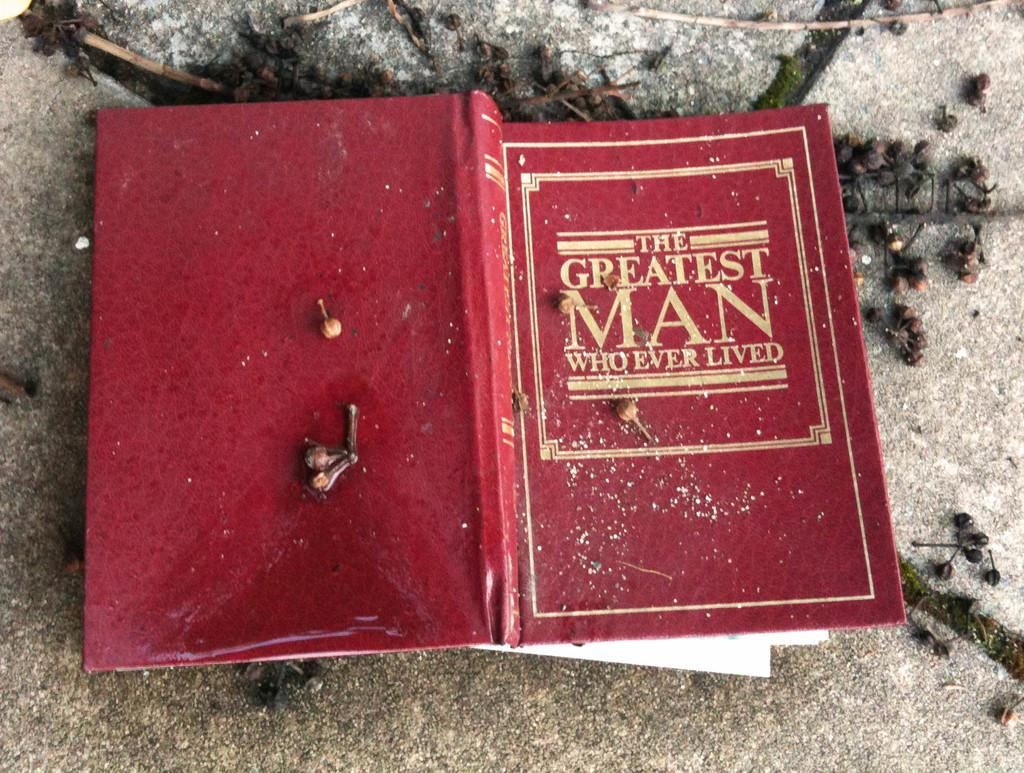<image>
Summarize the visual content of the image. A red book called The Greatest Man Who Ever Lived. 